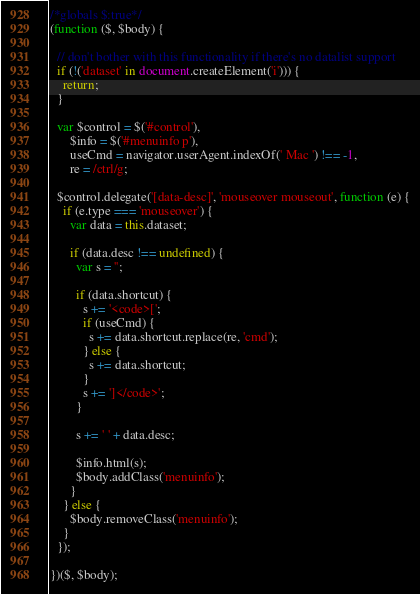Convert code to text. <code><loc_0><loc_0><loc_500><loc_500><_JavaScript_>/*globals $:true*/
(function ($, $body) {

  // don't bother with this functionality if there's no datalist support
  if (!('dataset' in document.createElement('i'))) {
    return;
  }

  var $control = $('#control'),
      $info = $('#menuinfo p'),
      useCmd = navigator.userAgent.indexOf(' Mac ') !== -1,
      re = /ctrl/g;

  $control.delegate('[data-desc]', 'mouseover mouseout', function (e) {
    if (e.type === 'mouseover') {
      var data = this.dataset;

      if (data.desc !== undefined) {
        var s = '';

        if (data.shortcut) {
          s += '<code>[';
          if (useCmd) {
            s += data.shortcut.replace(re, 'cmd');
          } else {
            s += data.shortcut;
          }
          s += ']</code>';
        }

        s += ' ' + data.desc;

        $info.html(s);
        $body.addClass('menuinfo');
      }
    } else {
      $body.removeClass('menuinfo');
    }
  });

})($, $body);
</code> 